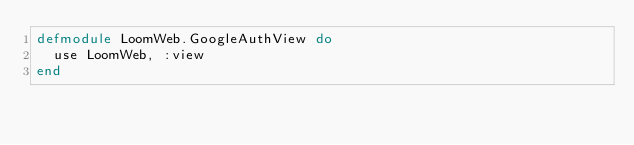<code> <loc_0><loc_0><loc_500><loc_500><_Elixir_>defmodule LoomWeb.GoogleAuthView do
  use LoomWeb, :view
end
</code> 